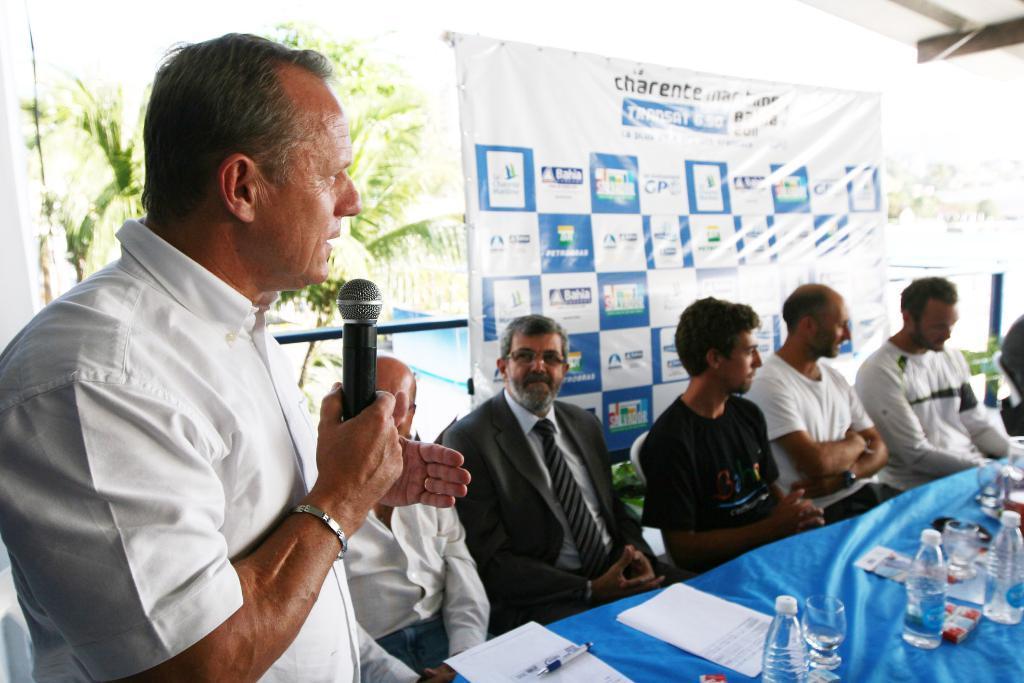Please provide a concise description of this image. In this image i can see a group of people are sitting on a chair in front of a table. On the table we have few bottles and other objects on it. I can also see a man is standing and holding a microphone in his hand. 